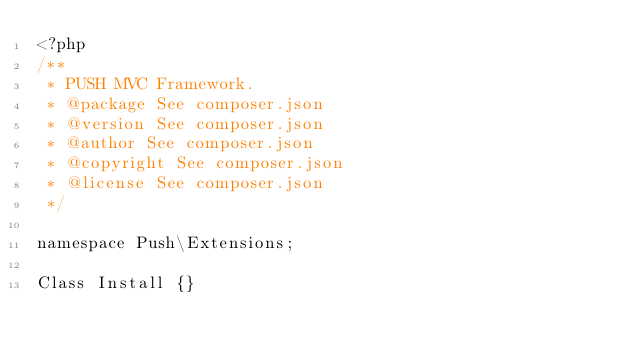<code> <loc_0><loc_0><loc_500><loc_500><_PHP_><?php
/**
 * PUSH MVC Framework.
 * @package See composer.json
 * @version See composer.json
 * @author See composer.json
 * @copyright See composer.json
 * @license See composer.json
 */

namespace Push\Extensions;

Class Install {}</code> 